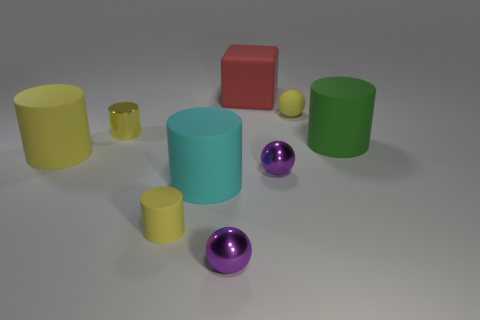Is the color of the large block the same as the big rubber object that is on the right side of the large red block?
Offer a very short reply. No. How many objects are either matte things in front of the yellow metal cylinder or balls that are behind the green matte cylinder?
Give a very brief answer. 5. Are there more matte objects behind the big yellow cylinder than big matte things that are in front of the small yellow sphere?
Offer a terse response. No. The small yellow object that is on the right side of the purple object in front of the cyan cylinder to the left of the yellow sphere is made of what material?
Offer a terse response. Rubber. Do the large rubber object to the left of the small yellow shiny cylinder and the big matte thing that is behind the large green rubber cylinder have the same shape?
Your response must be concise. No. Are there any blue balls that have the same size as the cyan cylinder?
Make the answer very short. No. What number of purple objects are either tiny rubber cylinders or tiny metal things?
Ensure brevity in your answer.  2. What number of large matte cylinders are the same color as the matte sphere?
Make the answer very short. 1. Is there any other thing that is the same shape as the cyan thing?
Give a very brief answer. Yes. What number of blocks are either tiny rubber things or large red objects?
Keep it short and to the point. 1. 